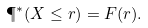Convert formula to latex. <formula><loc_0><loc_0><loc_500><loc_500>\P ^ { * } ( X \leq r ) = F ( r ) .</formula> 